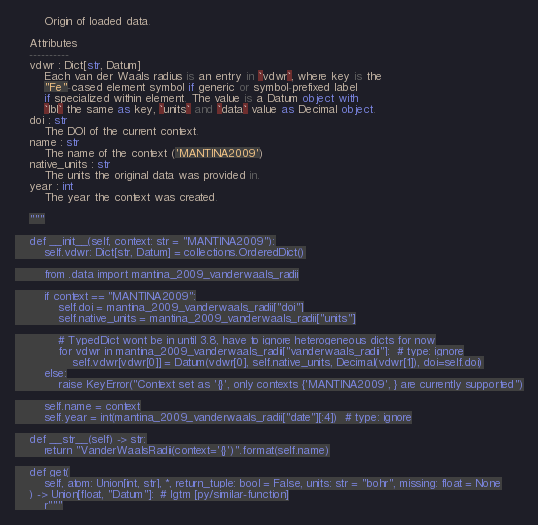<code> <loc_0><loc_0><loc_500><loc_500><_Python_>        Origin of loaded data.

    Attributes
    ----------
    vdwr : Dict[str, Datum]
        Each van der Waals radius is an entry in `vdwr`, where key is the
        "Fe"-cased element symbol if generic or symbol-prefixed label
        if specialized within element. The value is a Datum object with
        `lbl` the same as key, `units` and `data` value as Decimal object.
    doi : str
        The DOI of the current context.
    name : str
        The name of the context ('MANTINA2009')
    native_units : str
        The units the original data was provided in.
    year : int
        The year the context was created.

    """

    def __init__(self, context: str = "MANTINA2009"):
        self.vdwr: Dict[str, Datum] = collections.OrderedDict()

        from .data import mantina_2009_vanderwaals_radii

        if context == "MANTINA2009":
            self.doi = mantina_2009_vanderwaals_radii["doi"]
            self.native_units = mantina_2009_vanderwaals_radii["units"]

            # TypedDict wont be in until 3.8, have to ignore heterogeneous dicts for now
            for vdwr in mantina_2009_vanderwaals_radii["vanderwaals_radii"]:  # type: ignore
                self.vdwr[vdwr[0]] = Datum(vdwr[0], self.native_units, Decimal(vdwr[1]), doi=self.doi)
        else:
            raise KeyError("Context set as '{}', only contexts {'MANTINA2009', } are currently supported")

        self.name = context
        self.year = int(mantina_2009_vanderwaals_radii["date"][:4])  # type: ignore

    def __str__(self) -> str:
        return "VanderWaalsRadii(context='{}')".format(self.name)

    def get(
        self, atom: Union[int, str], *, return_tuple: bool = False, units: str = "bohr", missing: float = None
    ) -> Union[float, "Datum"]:  # lgtm [py/similar-function]
        r"""</code> 